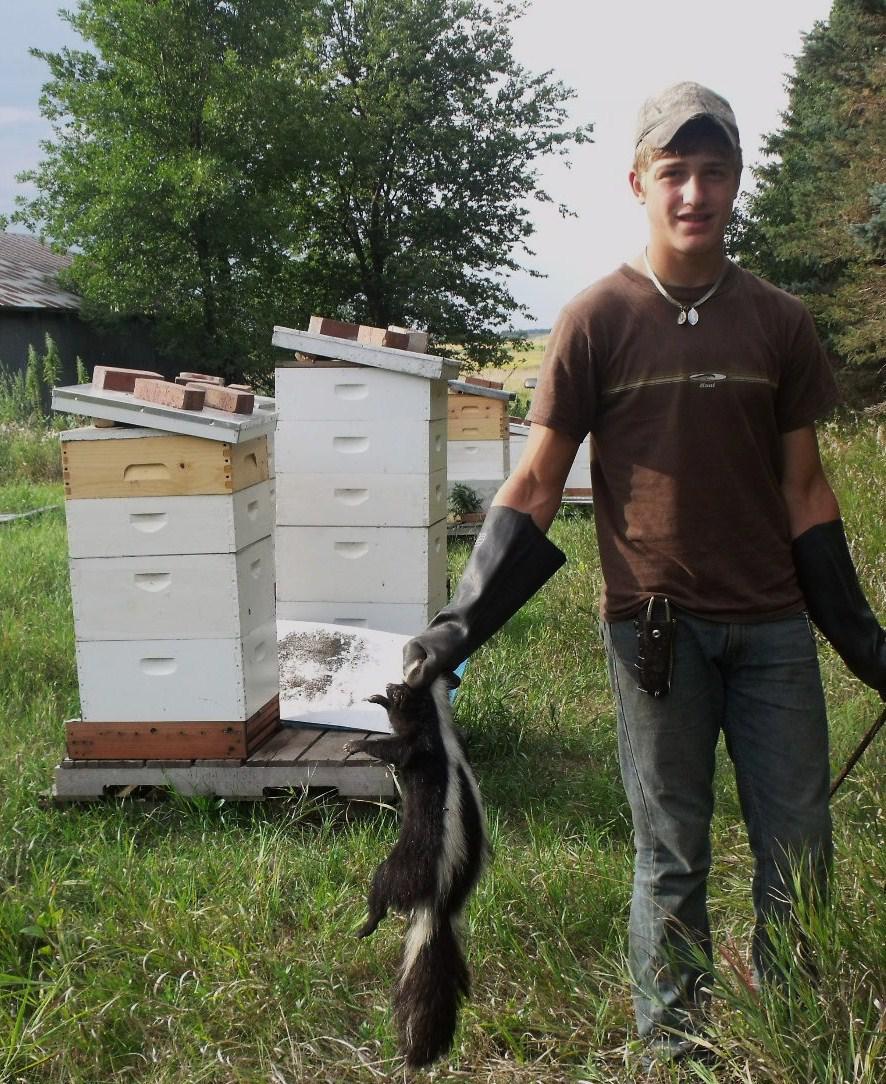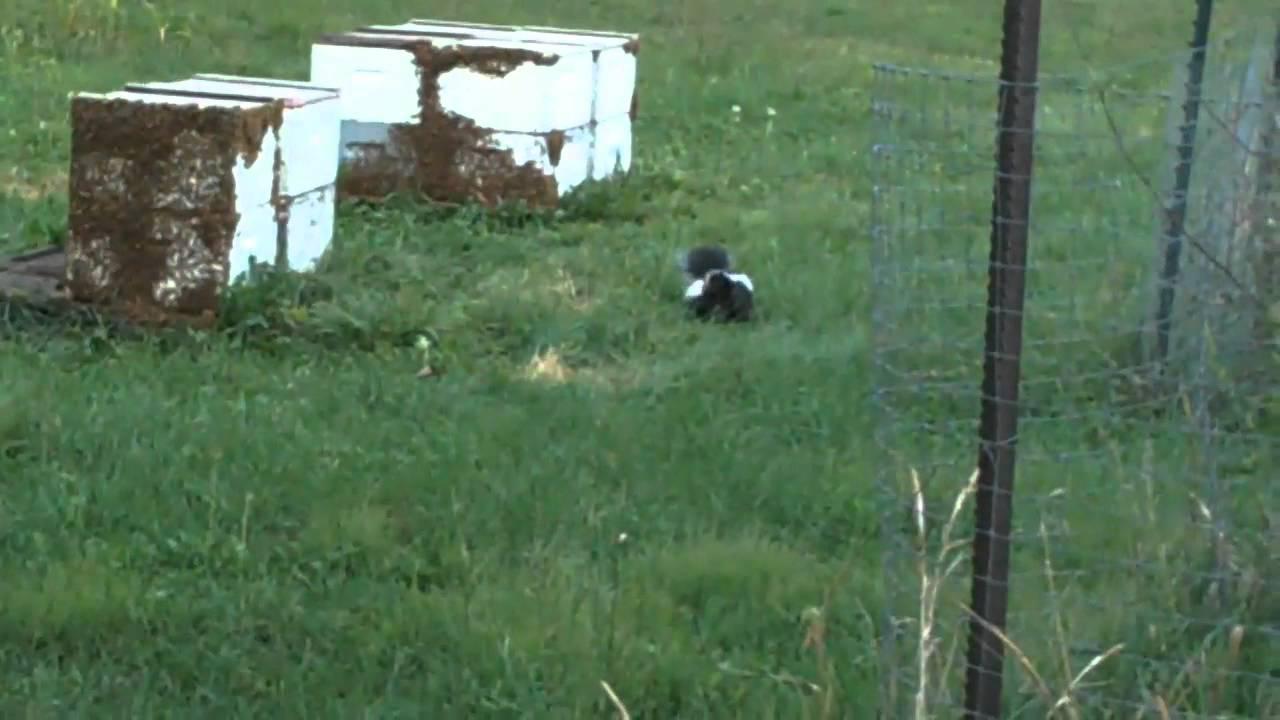The first image is the image on the left, the second image is the image on the right. Evaluate the accuracy of this statement regarding the images: "The skunk on the left is standing still and looking forward, and the skunk on the right is trotting in a horizontal path.". Is it true? Answer yes or no. No. The first image is the image on the left, the second image is the image on the right. Considering the images on both sides, is "In at least one image there is a black and white skunk in the grass with its body facing left." valid? Answer yes or no. No. 